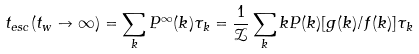Convert formula to latex. <formula><loc_0><loc_0><loc_500><loc_500>t _ { e s c } ( t _ { w } \to \infty ) = \sum _ { k } P ^ { \infty } ( k ) \tau _ { k } = \frac { 1 } { \mathcal { Z } } \sum _ { k } k P ( k ) [ g ( k ) / f ( k ) ] \tau _ { k }</formula> 